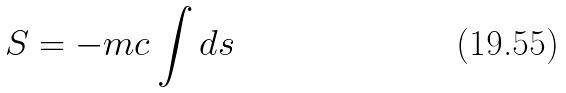Convert formula to latex. <formula><loc_0><loc_0><loc_500><loc_500>S = - m c \int d s</formula> 